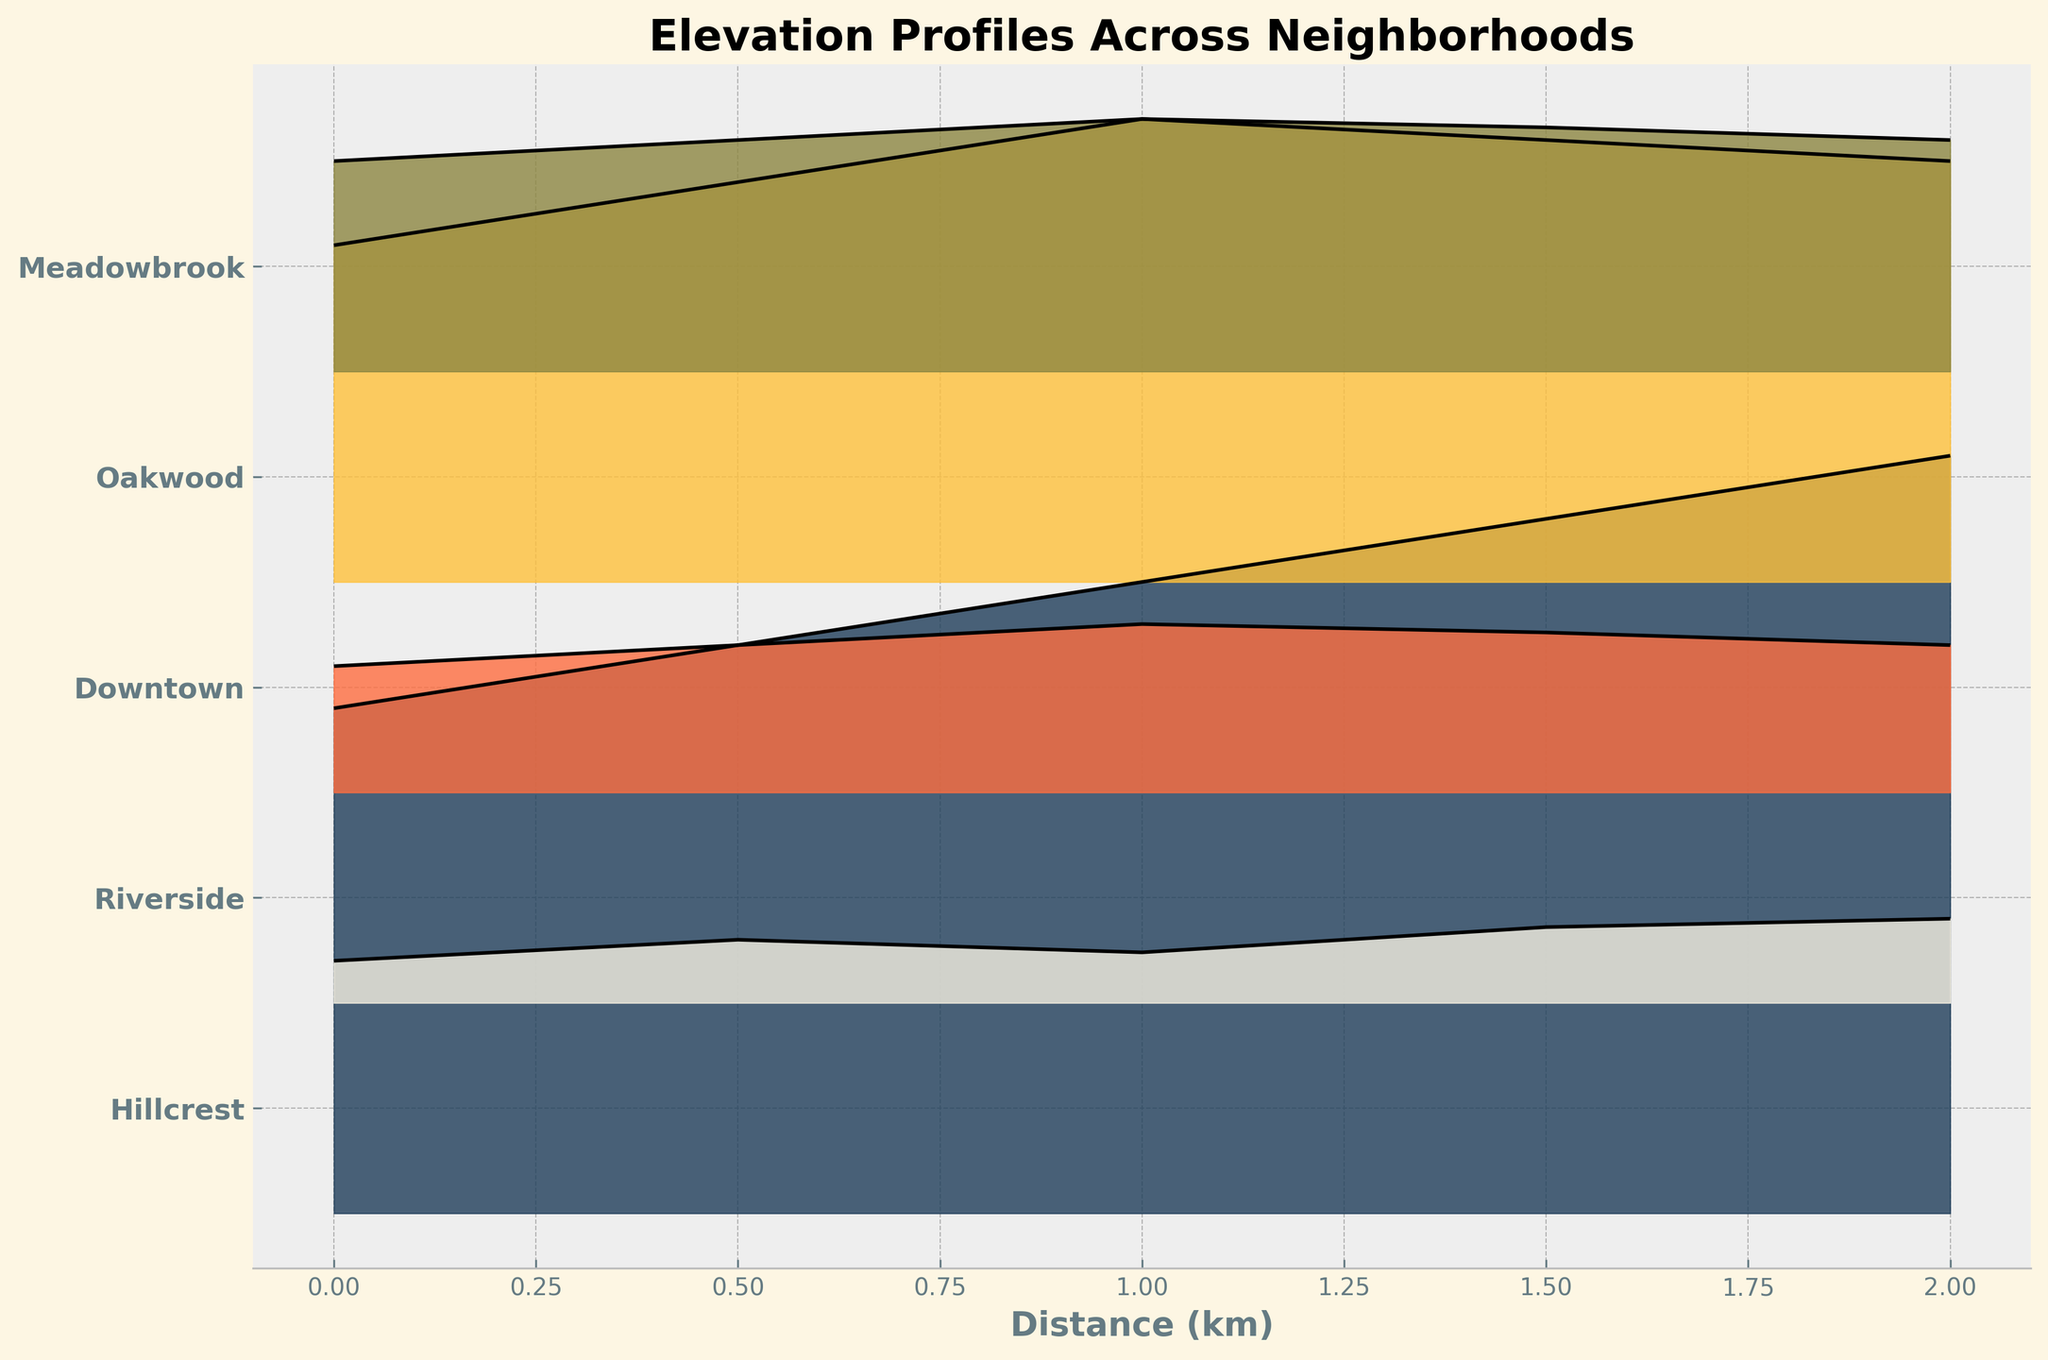what is the title of the plot? The title of the plot is displayed at the top and provides an overview of what the plot represents.
Answer: Elevation Profiles Across Neighborhoods how many neighborhoods are represented in the plot? Count the number of unique labels on the y-axis, which represent the different neighborhoods.
Answer: 5 which neighborhood has the highest starting elevation? Look at the y-axis labels and the starting points of the elevation profiles on the x-axis to identify the neighborhood with the highest starting elevation.
Answer: Hillcrest how does the elevation profile of Hillcrest compare to Riverside? To compare, observe the shapes and heights of the filled areas for Hillcrest and Riverside. Hillcrest has a higher and rising elevation profile compared to Riverside, which is relatively flat.
Answer: Hillcrest rises more steeply than Riverside which neighborhood has the most fluctuation in elevation? Look at the variations in the elevation profiles for each neighborhood. The neighborhood with the largest ups and downs in the plot has the most fluctuation.
Answer: Oakwood what is the common range of distance covered for all neighborhoods? Observe the x-axis to find the range of distance over which all elevation profiles are plotted.
Answer: 0 to 2 km which neighborhood ends with the highest elevation? Trace the endpoint of each neighborhood's elevation profile and compare the heights.
Answer: Hillcrest what is the average elevation change in Downtown? Compare the start and end elevations in Downtown by taking the difference and dividing by the total distance covered, then average them over the segments. (40 - 30)/2 + (40 - 35)/1.5 + (40 - 38)/1 + (40 - 35)/2 / 4
Answer: 7.4 units is there any neighborhood whose elevation profile decreases over distance? Look at the general trend of each elevation profile. Identify if any profile descends instead of ascending or staying flat.
Answer: No how does the elevation profile of Meadowbrook compare to Oakwood? To compare, observe the shapes and heights of the filled areas. Meadowbrook's profile is relatively flat compared to Oakwood, which has significant ups and downs.
Answer: Meadowbrook is flatter than Oakwood 